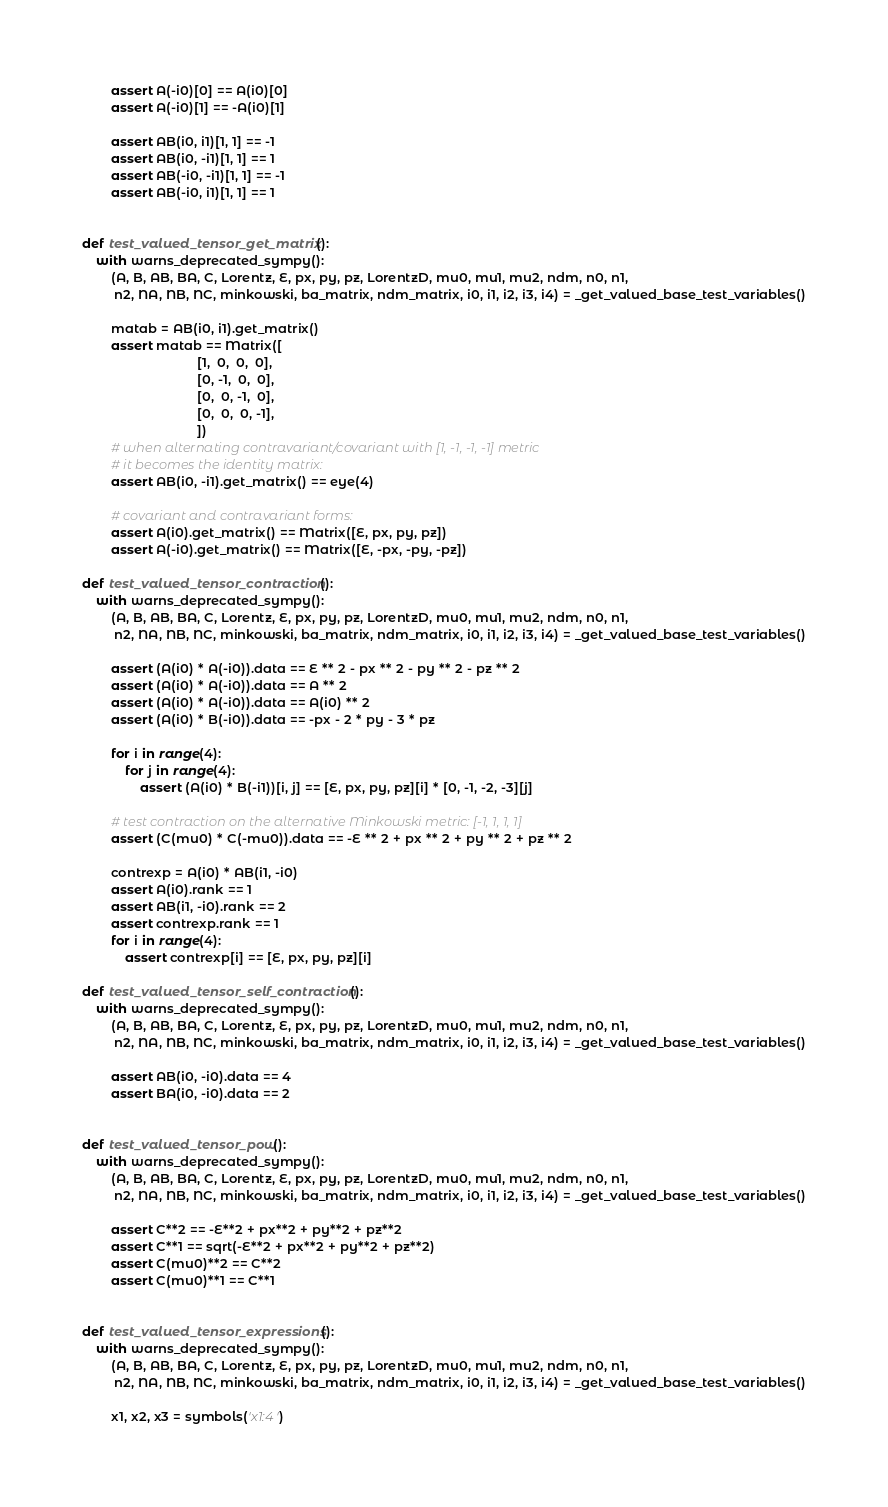Convert code to text. <code><loc_0><loc_0><loc_500><loc_500><_Python_>        assert A(-i0)[0] == A(i0)[0]
        assert A(-i0)[1] == -A(i0)[1]

        assert AB(i0, i1)[1, 1] == -1
        assert AB(i0, -i1)[1, 1] == 1
        assert AB(-i0, -i1)[1, 1] == -1
        assert AB(-i0, i1)[1, 1] == 1


def test_valued_tensor_get_matrix():
    with warns_deprecated_sympy():
        (A, B, AB, BA, C, Lorentz, E, px, py, pz, LorentzD, mu0, mu1, mu2, ndm, n0, n1,
         n2, NA, NB, NC, minkowski, ba_matrix, ndm_matrix, i0, i1, i2, i3, i4) = _get_valued_base_test_variables()

        matab = AB(i0, i1).get_matrix()
        assert matab == Matrix([
                                [1,  0,  0,  0],
                                [0, -1,  0,  0],
                                [0,  0, -1,  0],
                                [0,  0,  0, -1],
                                ])
        # when alternating contravariant/covariant with [1, -1, -1, -1] metric
        # it becomes the identity matrix:
        assert AB(i0, -i1).get_matrix() == eye(4)

        # covariant and contravariant forms:
        assert A(i0).get_matrix() == Matrix([E, px, py, pz])
        assert A(-i0).get_matrix() == Matrix([E, -px, -py, -pz])

def test_valued_tensor_contraction():
    with warns_deprecated_sympy():
        (A, B, AB, BA, C, Lorentz, E, px, py, pz, LorentzD, mu0, mu1, mu2, ndm, n0, n1,
         n2, NA, NB, NC, minkowski, ba_matrix, ndm_matrix, i0, i1, i2, i3, i4) = _get_valued_base_test_variables()

        assert (A(i0) * A(-i0)).data == E ** 2 - px ** 2 - py ** 2 - pz ** 2
        assert (A(i0) * A(-i0)).data == A ** 2
        assert (A(i0) * A(-i0)).data == A(i0) ** 2
        assert (A(i0) * B(-i0)).data == -px - 2 * py - 3 * pz

        for i in range(4):
            for j in range(4):
                assert (A(i0) * B(-i1))[i, j] == [E, px, py, pz][i] * [0, -1, -2, -3][j]

        # test contraction on the alternative Minkowski metric: [-1, 1, 1, 1]
        assert (C(mu0) * C(-mu0)).data == -E ** 2 + px ** 2 + py ** 2 + pz ** 2

        contrexp = A(i0) * AB(i1, -i0)
        assert A(i0).rank == 1
        assert AB(i1, -i0).rank == 2
        assert contrexp.rank == 1
        for i in range(4):
            assert contrexp[i] == [E, px, py, pz][i]

def test_valued_tensor_self_contraction():
    with warns_deprecated_sympy():
        (A, B, AB, BA, C, Lorentz, E, px, py, pz, LorentzD, mu0, mu1, mu2, ndm, n0, n1,
         n2, NA, NB, NC, minkowski, ba_matrix, ndm_matrix, i0, i1, i2, i3, i4) = _get_valued_base_test_variables()

        assert AB(i0, -i0).data == 4
        assert BA(i0, -i0).data == 2


def test_valued_tensor_pow():
    with warns_deprecated_sympy():
        (A, B, AB, BA, C, Lorentz, E, px, py, pz, LorentzD, mu0, mu1, mu2, ndm, n0, n1,
         n2, NA, NB, NC, minkowski, ba_matrix, ndm_matrix, i0, i1, i2, i3, i4) = _get_valued_base_test_variables()

        assert C**2 == -E**2 + px**2 + py**2 + pz**2
        assert C**1 == sqrt(-E**2 + px**2 + py**2 + pz**2)
        assert C(mu0)**2 == C**2
        assert C(mu0)**1 == C**1


def test_valued_tensor_expressions():
    with warns_deprecated_sympy():
        (A, B, AB, BA, C, Lorentz, E, px, py, pz, LorentzD, mu0, mu1, mu2, ndm, n0, n1,
         n2, NA, NB, NC, minkowski, ba_matrix, ndm_matrix, i0, i1, i2, i3, i4) = _get_valued_base_test_variables()

        x1, x2, x3 = symbols('x1:4')
</code> 